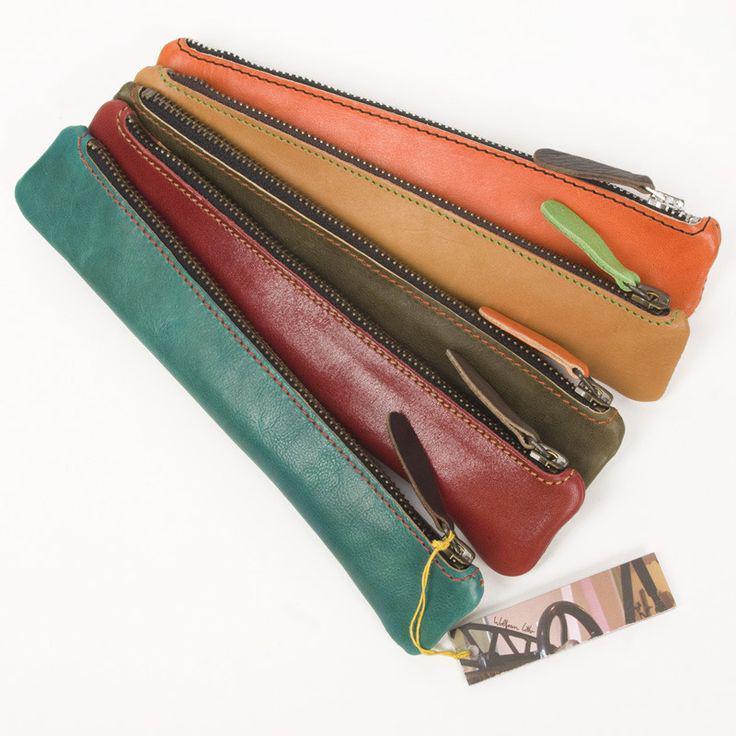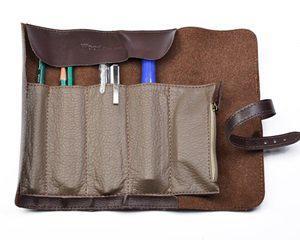The first image is the image on the left, the second image is the image on the right. Considering the images on both sides, is "An image shows one leather pencil case, displayed open with writing implements tucked inside." valid? Answer yes or no. Yes. The first image is the image on the left, the second image is the image on the right. Given the left and right images, does the statement "In one image, a leather pencil case is displayed closed in at least four colors, while the other image displays how a different brown case looks when opened." hold true? Answer yes or no. Yes. 